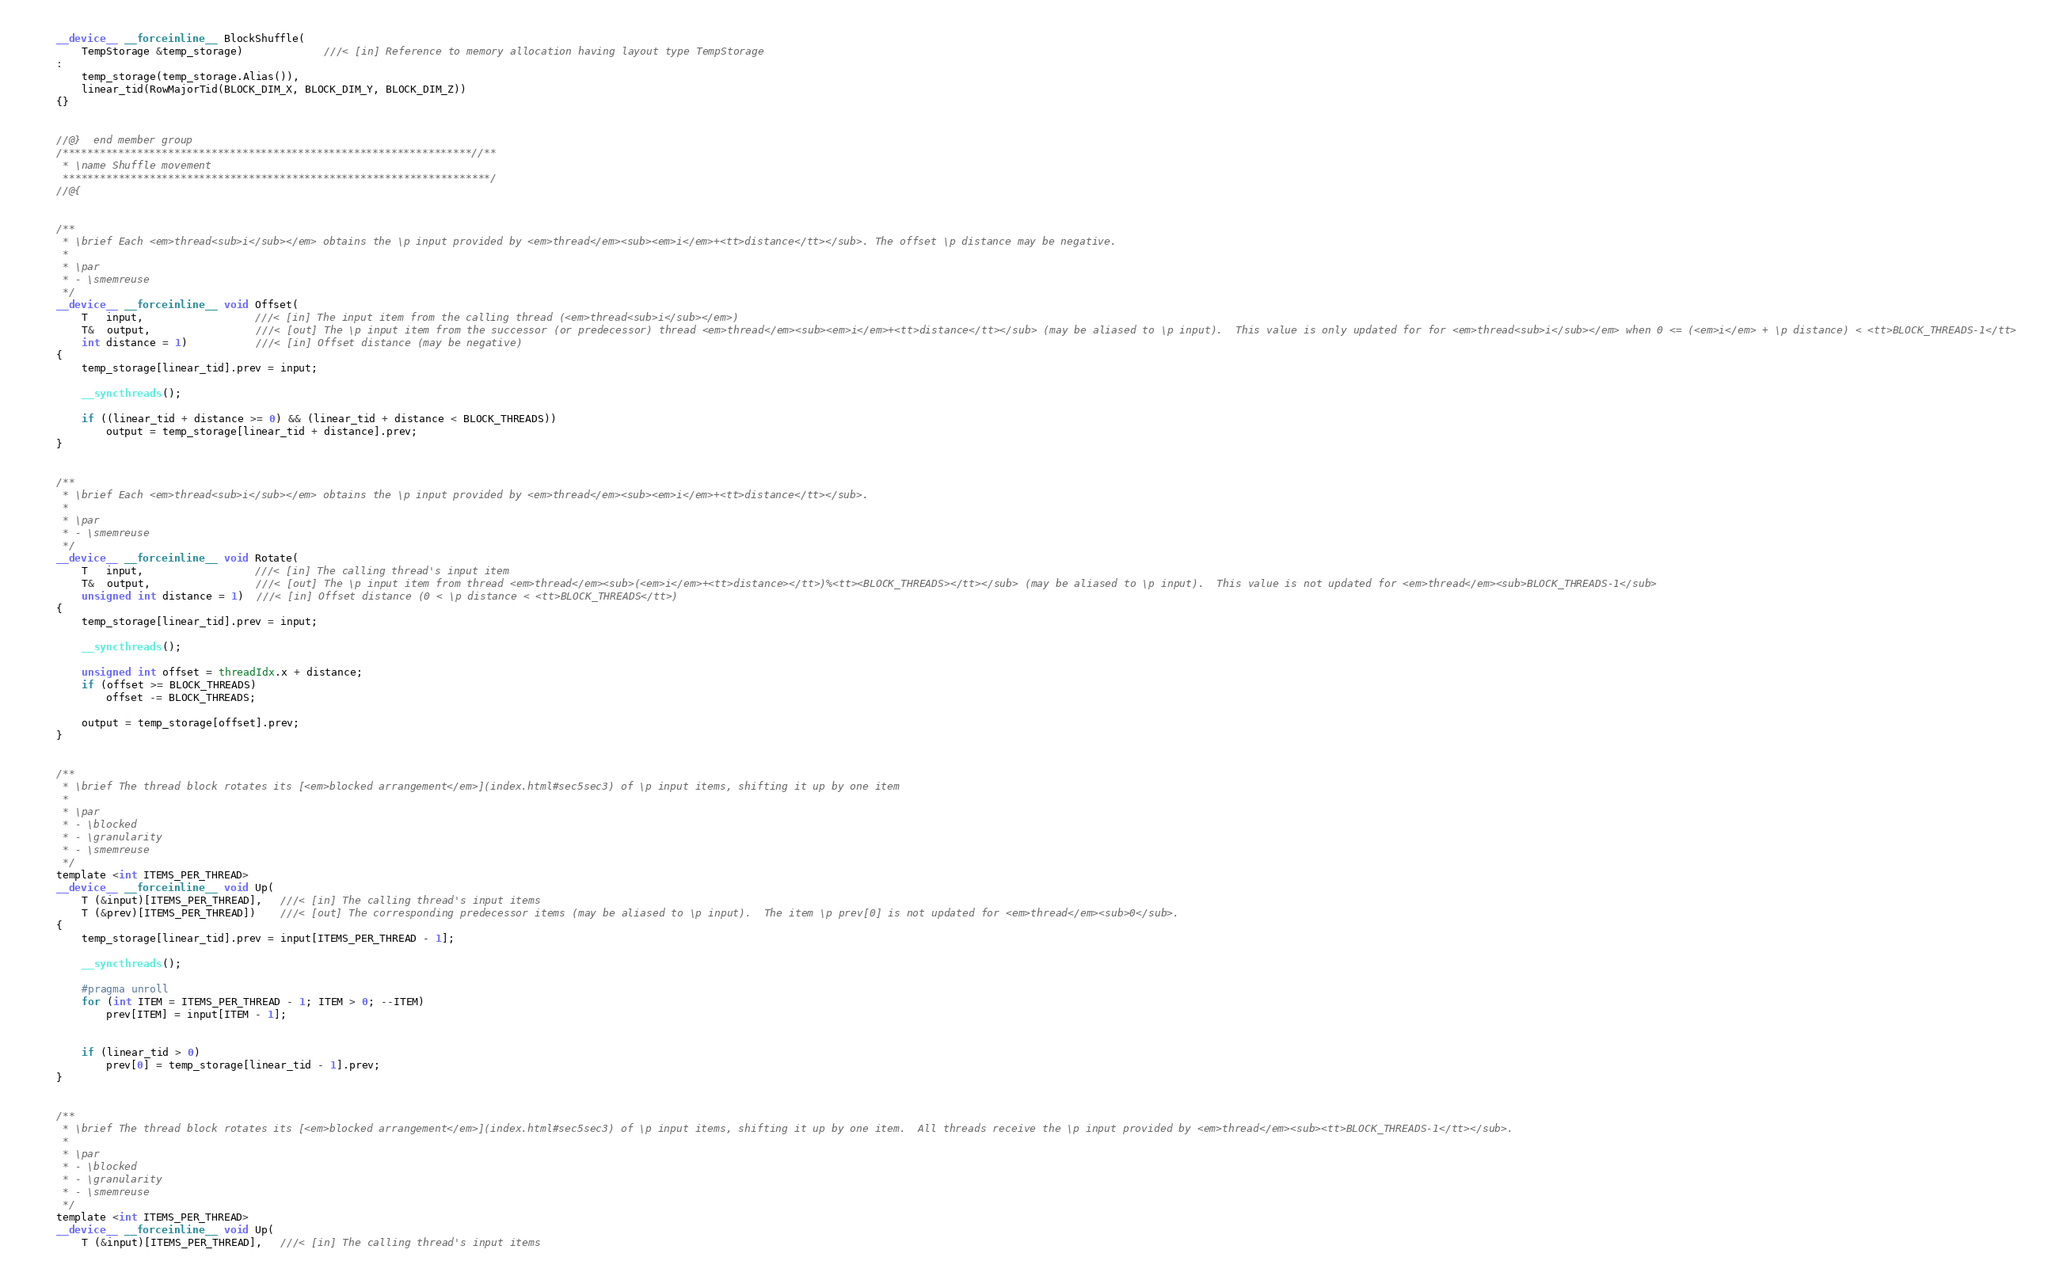<code> <loc_0><loc_0><loc_500><loc_500><_Cuda_>    __device__ __forceinline__ BlockShuffle(
        TempStorage &temp_storage)             ///< [in] Reference to memory allocation having layout type TempStorage
    :
        temp_storage(temp_storage.Alias()),
        linear_tid(RowMajorTid(BLOCK_DIM_X, BLOCK_DIM_Y, BLOCK_DIM_Z))
    {}


    //@}  end member group
    /******************************************************************//**
     * \name Shuffle movement
     *********************************************************************/
    //@{


    /**
     * \brief Each <em>thread<sub>i</sub></em> obtains the \p input provided by <em>thread</em><sub><em>i</em>+<tt>distance</tt></sub>. The offset \p distance may be negative.
     *
     * \par
     * - \smemreuse
     */
    __device__ __forceinline__ void Offset(
        T   input,                  ///< [in] The input item from the calling thread (<em>thread<sub>i</sub></em>)
        T&  output,                 ///< [out] The \p input item from the successor (or predecessor) thread <em>thread</em><sub><em>i</em>+<tt>distance</tt></sub> (may be aliased to \p input).  This value is only updated for for <em>thread<sub>i</sub></em> when 0 <= (<em>i</em> + \p distance) < <tt>BLOCK_THREADS-1</tt>
        int distance = 1)           ///< [in] Offset distance (may be negative)
    {
        temp_storage[linear_tid].prev = input;

        __syncthreads();

        if ((linear_tid + distance >= 0) && (linear_tid + distance < BLOCK_THREADS))
            output = temp_storage[linear_tid + distance].prev;
    }


    /**
     * \brief Each <em>thread<sub>i</sub></em> obtains the \p input provided by <em>thread</em><sub><em>i</em>+<tt>distance</tt></sub>.
     *
     * \par
     * - \smemreuse
     */
    __device__ __forceinline__ void Rotate(
        T   input,                  ///< [in] The calling thread's input item
        T&  output,                 ///< [out] The \p input item from thread <em>thread</em><sub>(<em>i</em>+<tt>distance></tt>)%<tt><BLOCK_THREADS></tt></sub> (may be aliased to \p input).  This value is not updated for <em>thread</em><sub>BLOCK_THREADS-1</sub>
        unsigned int distance = 1)  ///< [in] Offset distance (0 < \p distance < <tt>BLOCK_THREADS</tt>)
    {
        temp_storage[linear_tid].prev = input;

        __syncthreads();

        unsigned int offset = threadIdx.x + distance;
        if (offset >= BLOCK_THREADS)
            offset -= BLOCK_THREADS;

        output = temp_storage[offset].prev;
    }


    /**
     * \brief The thread block rotates its [<em>blocked arrangement</em>](index.html#sec5sec3) of \p input items, shifting it up by one item
     *
     * \par
     * - \blocked
     * - \granularity
     * - \smemreuse
     */
    template <int ITEMS_PER_THREAD>
    __device__ __forceinline__ void Up(
        T (&input)[ITEMS_PER_THREAD],   ///< [in] The calling thread's input items
        T (&prev)[ITEMS_PER_THREAD])    ///< [out] The corresponding predecessor items (may be aliased to \p input).  The item \p prev[0] is not updated for <em>thread</em><sub>0</sub>.
    {
        temp_storage[linear_tid].prev = input[ITEMS_PER_THREAD - 1];

        __syncthreads();

        #pragma unroll
        for (int ITEM = ITEMS_PER_THREAD - 1; ITEM > 0; --ITEM)
            prev[ITEM] = input[ITEM - 1];


        if (linear_tid > 0)
            prev[0] = temp_storage[linear_tid - 1].prev;
    }


    /**
     * \brief The thread block rotates its [<em>blocked arrangement</em>](index.html#sec5sec3) of \p input items, shifting it up by one item.  All threads receive the \p input provided by <em>thread</em><sub><tt>BLOCK_THREADS-1</tt></sub>.
     *
     * \par
     * - \blocked
     * - \granularity
     * - \smemreuse
     */
    template <int ITEMS_PER_THREAD>
    __device__ __forceinline__ void Up(
        T (&input)[ITEMS_PER_THREAD],   ///< [in] The calling thread's input items</code> 